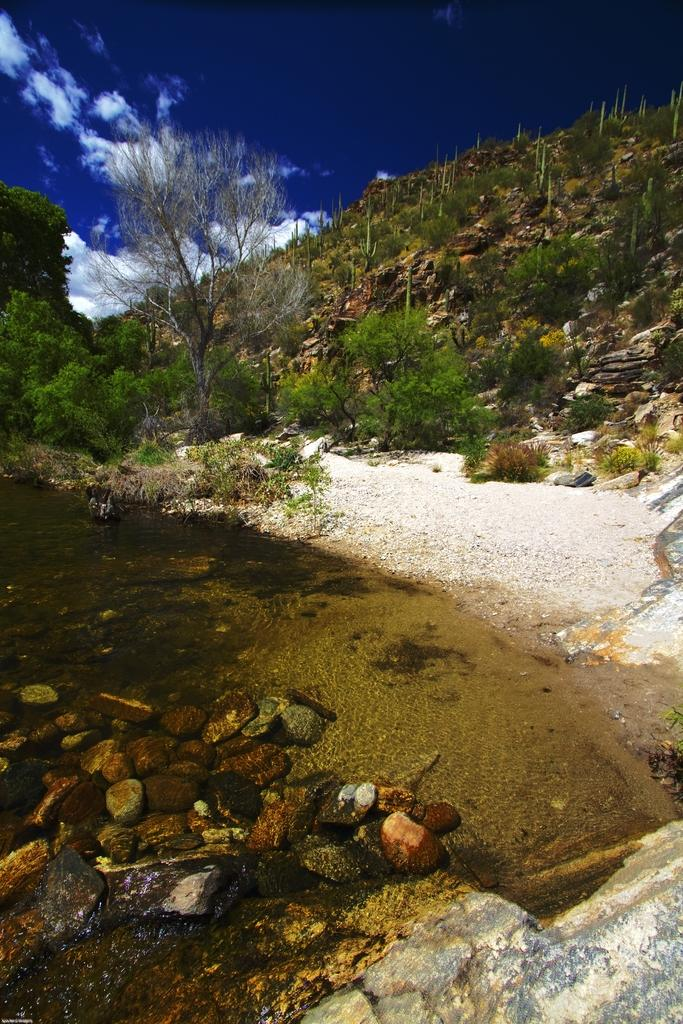What type of natural formation can be seen in the image? There are mountains in the image. What is covering the mountains? The mountains have trees. What is visible at the bottom of the image? There are stones at the bottom of the image. What is visible at the top of the image? The sky is visible at the top of the image. What can be seen in the sky? Clouds are present in the sky. What type of acoustics can be heard in the image? There is no sound or acoustics present in the image, as it is a still photograph. Is there a ball visible in the image? No, there is no ball present in the image. 